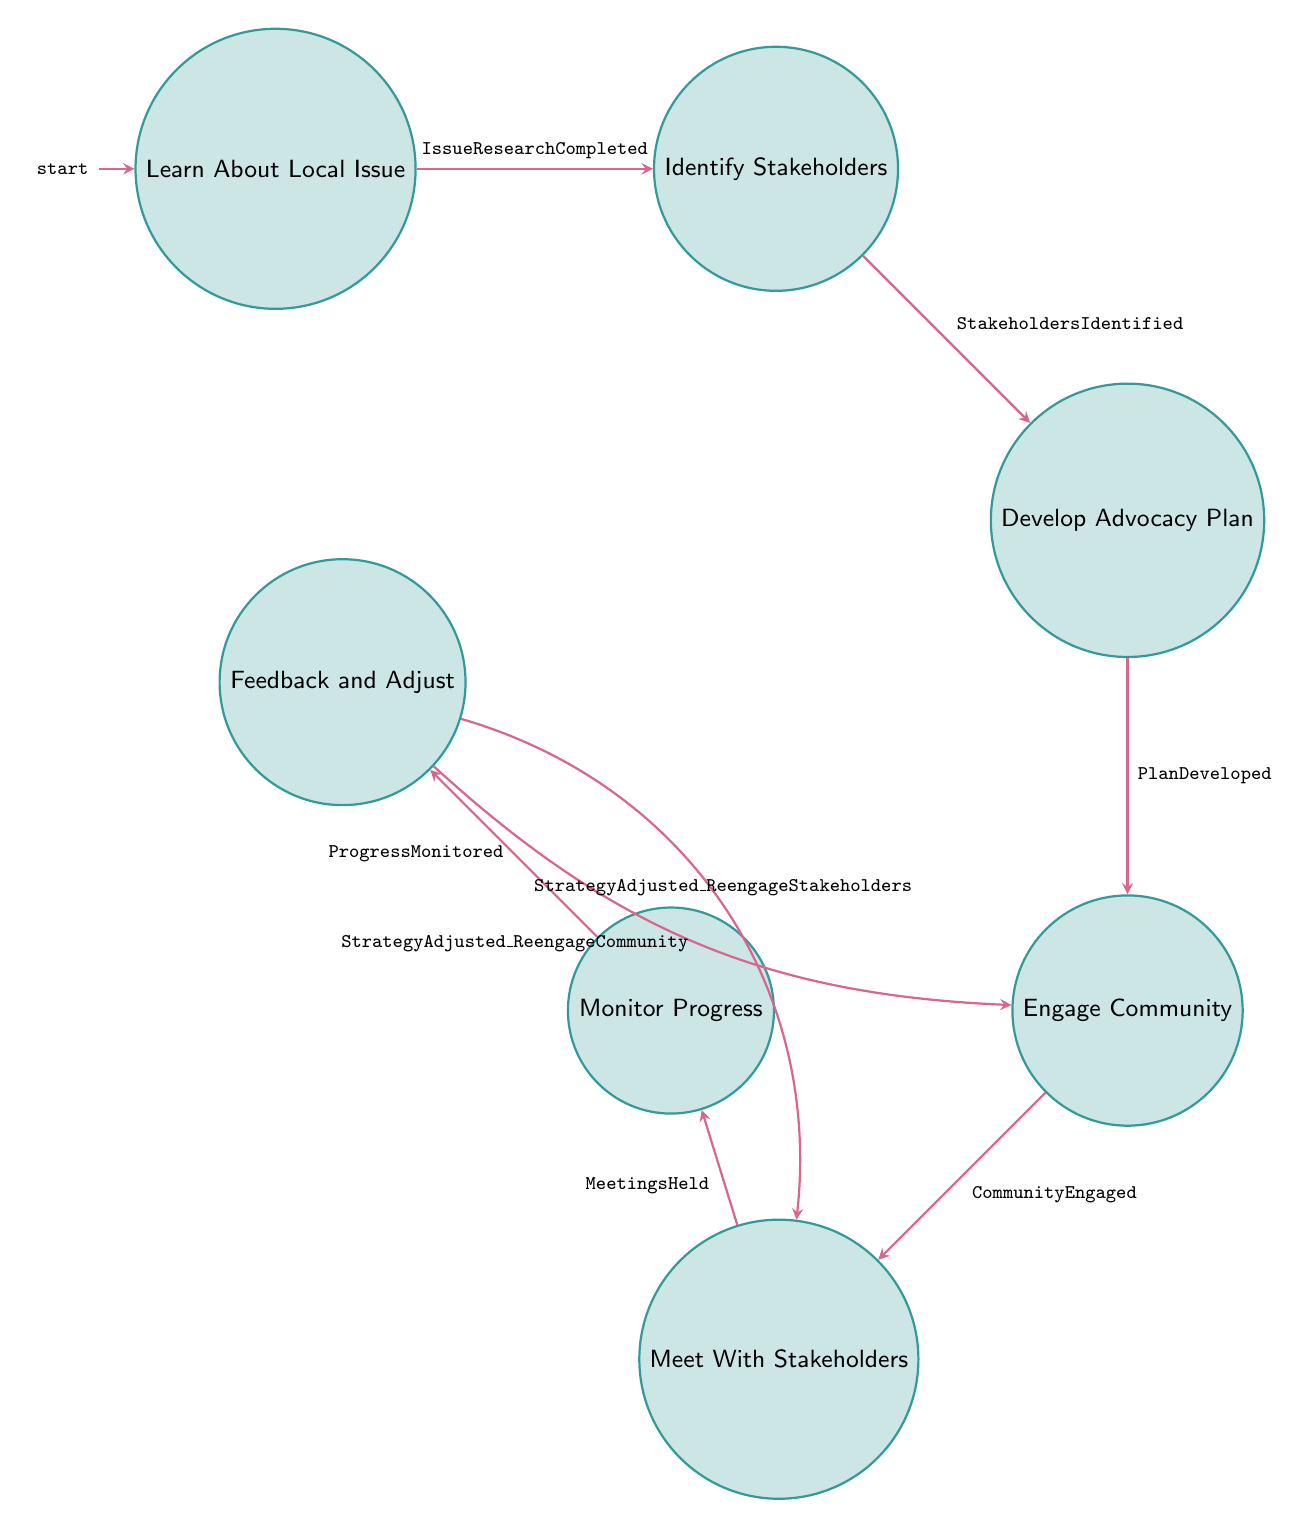What is the first state in the sequence? The first state in the Finite State Machine diagram is labeled "Learn About Local Issue." It is the initial state from which all other states are reached.
Answer: Learn About Local Issue How many states are there in total? There are a total of seven states depicted in the diagram: Learn About Local Issue, Identify Stakeholders, Develop Advocacy Plan, Engage Community, Meet With Stakeholders, Monitor Progress, and Feedback and Adjust. By counting each state, we find the total is seven.
Answer: Seven What is the transition event from "Engage Community"? The transition event from "Engage Community" to "Meet With Stakeholders" is labeled "CommunityEngaged." This indicates what must happen in order to move to the next state from Engage Community.
Answer: Community Engaged Which state follows "Identify Stakeholders"? The state that follows "Identify Stakeholders" is "Develop Advocacy Plan." This is a direct transition as indicated in the diagram.
Answer: Develop Advocacy Plan What happens after "Monitor Progress"? After "Monitor Progress," the next possible state is "Feedback and Adjust," as indicated by the transition event labeled "ProgressMonitored." This shows that monitoring leads to a reassessment stage.
Answer: Feedback and Adjust What is one potential re-engagement option from "Feedback and Adjust"? From "Feedback and Adjust," one potential re-engagement option is "Engage Community." This indicates that after feedback is gathered and adjustments are made, students can return to engage the community again.
Answer: Engage Community How many edges connect the "Develop Advocacy Plan" state? The "Develop Advocacy Plan" state has exactly one edge connecting it, which leads to the "Engage Community" state. This indicates it has only one direct transition out.
Answer: One What is the purpose of the "Meet With Stakeholders" state? The purpose of the "Meet With Stakeholders" state is to arrange meetings with stakeholders to present the advocacy case and seek their support, as detailed in the state's description.
Answer: Arrange meetings with stakeholders What does the transition "StrategyAdjusted_ReengageStakeholders" signify? The transition labeled "StrategyAdjusted_ReengageStakeholders" signifies that after feedback is gathered and the strategy is adjusted, there is an opportunity to re-engage the stakeholders again based on the new plan.
Answer: Re-engage stakeholders 